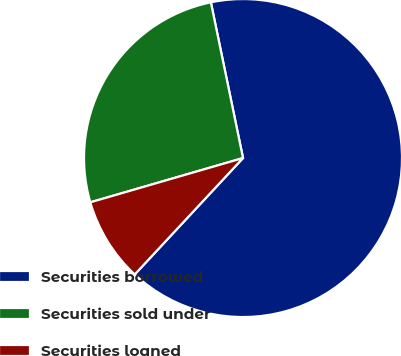<chart> <loc_0><loc_0><loc_500><loc_500><pie_chart><fcel>Securities borrowed<fcel>Securities sold under<fcel>Securities loaned<nl><fcel>65.16%<fcel>26.25%<fcel>8.58%<nl></chart> 